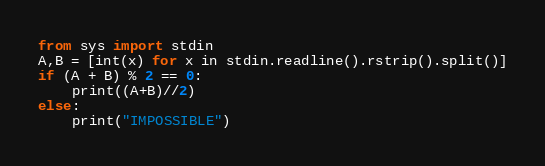Convert code to text. <code><loc_0><loc_0><loc_500><loc_500><_Python_>from sys import stdin
A,B = [int(x) for x in stdin.readline().rstrip().split()]
if (A + B) % 2 == 0:
    print((A+B)//2)
else:
    print("IMPOSSIBLE")</code> 